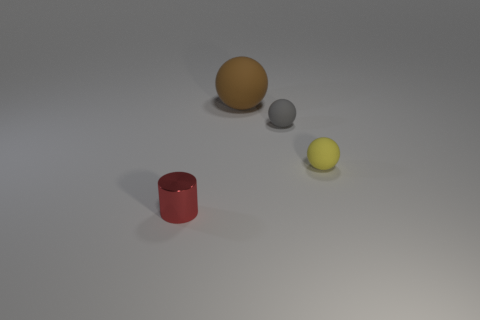What shape is the small gray object that is made of the same material as the large brown sphere?
Provide a succinct answer. Sphere. Are there any brown matte cylinders?
Your answer should be very brief. No. Are there fewer small gray matte spheres to the right of the brown sphere than matte balls that are right of the yellow rubber thing?
Keep it short and to the point. No. What is the shape of the matte object in front of the gray rubber ball?
Your answer should be compact. Sphere. Is the material of the brown sphere the same as the tiny red object?
Offer a terse response. No. Are there any other things that are made of the same material as the red thing?
Give a very brief answer. No. There is another gray object that is the same shape as the big object; what is its material?
Ensure brevity in your answer.  Rubber. Is the number of small gray matte things that are on the left side of the big sphere less than the number of large brown matte spheres?
Your response must be concise. Yes. What number of things are behind the small metal cylinder?
Offer a very short reply. 3. There is a small rubber object right of the tiny gray sphere; is its shape the same as the big brown rubber object that is behind the tiny yellow thing?
Provide a succinct answer. Yes. 